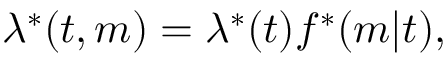<formula> <loc_0><loc_0><loc_500><loc_500>\lambda ^ { * } ( t , m ) = \lambda ^ { * } ( t ) f ^ { * } ( m | t ) ,</formula> 